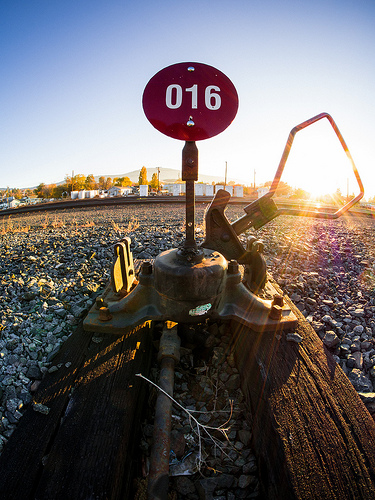<image>
Is there a sign in front of the tree? Yes. The sign is positioned in front of the tree, appearing closer to the camera viewpoint. 